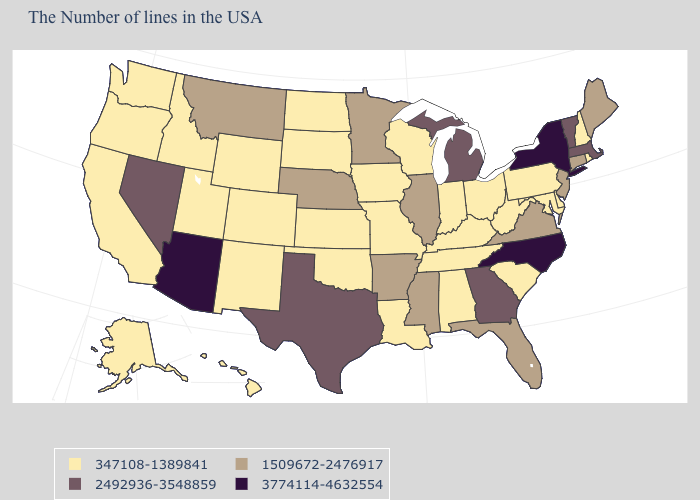Name the states that have a value in the range 1509672-2476917?
Answer briefly. Maine, Connecticut, New Jersey, Virginia, Florida, Illinois, Mississippi, Arkansas, Minnesota, Nebraska, Montana. Name the states that have a value in the range 2492936-3548859?
Be succinct. Massachusetts, Vermont, Georgia, Michigan, Texas, Nevada. What is the value of Pennsylvania?
Concise answer only. 347108-1389841. Which states have the lowest value in the USA?
Concise answer only. Rhode Island, New Hampshire, Delaware, Maryland, Pennsylvania, South Carolina, West Virginia, Ohio, Kentucky, Indiana, Alabama, Tennessee, Wisconsin, Louisiana, Missouri, Iowa, Kansas, Oklahoma, South Dakota, North Dakota, Wyoming, Colorado, New Mexico, Utah, Idaho, California, Washington, Oregon, Alaska, Hawaii. What is the value of Illinois?
Write a very short answer. 1509672-2476917. What is the highest value in the MidWest ?
Keep it brief. 2492936-3548859. Among the states that border Mississippi , does Tennessee have the lowest value?
Write a very short answer. Yes. What is the value of Idaho?
Keep it brief. 347108-1389841. What is the lowest value in the South?
Write a very short answer. 347108-1389841. What is the value of Nevada?
Answer briefly. 2492936-3548859. Does Nebraska have a lower value than South Dakota?
Be succinct. No. What is the value of Tennessee?
Give a very brief answer. 347108-1389841. Does the first symbol in the legend represent the smallest category?
Short answer required. Yes. Among the states that border Kentucky , which have the lowest value?
Be succinct. West Virginia, Ohio, Indiana, Tennessee, Missouri. Name the states that have a value in the range 1509672-2476917?
Answer briefly. Maine, Connecticut, New Jersey, Virginia, Florida, Illinois, Mississippi, Arkansas, Minnesota, Nebraska, Montana. 